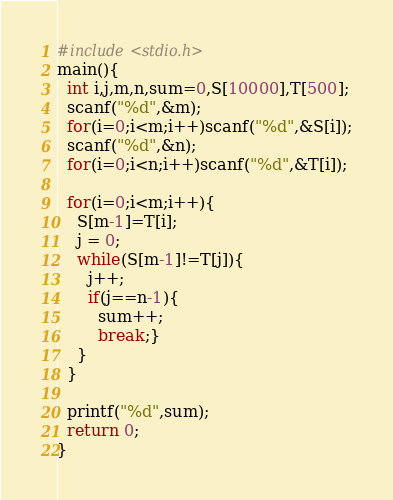<code> <loc_0><loc_0><loc_500><loc_500><_C_>#include<stdio.h>
main(){
  int i,j,m,n,sum=0,S[10000],T[500];
  scanf("%d",&m);
  for(i=0;i<m;i++)scanf("%d",&S[i]);
  scanf("%d",&n);
  for(i=0;i<n;i++)scanf("%d",&T[i]);

  for(i=0;i<m;i++){
    S[m-1]=T[i];
    j = 0;
    while(S[m-1]!=T[j]){
      j++;
      if(j==n-1){
        sum++;
        break;}
    }
  }

  printf("%d",sum);
  return 0;
}</code> 